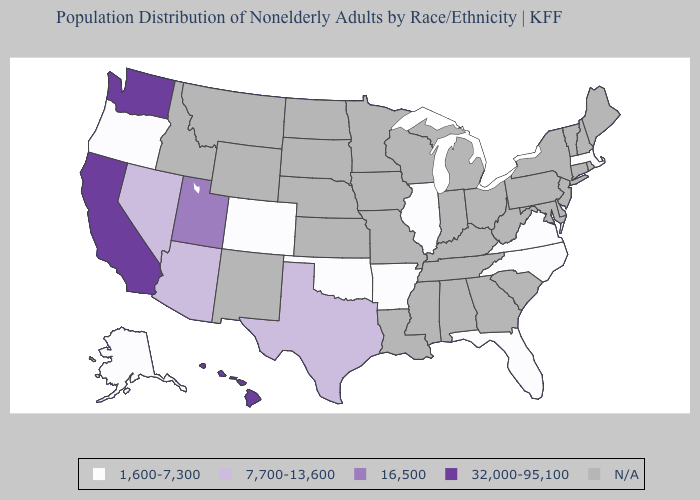What is the value of Mississippi?
Answer briefly. N/A. Name the states that have a value in the range 16,500?
Write a very short answer. Utah. What is the value of Iowa?
Answer briefly. N/A. Among the states that border West Virginia , which have the highest value?
Concise answer only. Virginia. Which states have the lowest value in the USA?
Be succinct. Alaska, Arkansas, Colorado, Florida, Illinois, Massachusetts, North Carolina, Oklahoma, Oregon, Virginia. What is the value of North Dakota?
Answer briefly. N/A. How many symbols are there in the legend?
Write a very short answer. 5. Does Virginia have the lowest value in the USA?
Be succinct. Yes. Name the states that have a value in the range N/A?
Answer briefly. Alabama, Connecticut, Delaware, Georgia, Idaho, Indiana, Iowa, Kansas, Kentucky, Louisiana, Maine, Maryland, Michigan, Minnesota, Mississippi, Missouri, Montana, Nebraska, New Hampshire, New Jersey, New Mexico, New York, North Dakota, Ohio, Pennsylvania, Rhode Island, South Carolina, South Dakota, Tennessee, Vermont, West Virginia, Wisconsin, Wyoming. What is the highest value in the Northeast ?
Give a very brief answer. 1,600-7,300. 